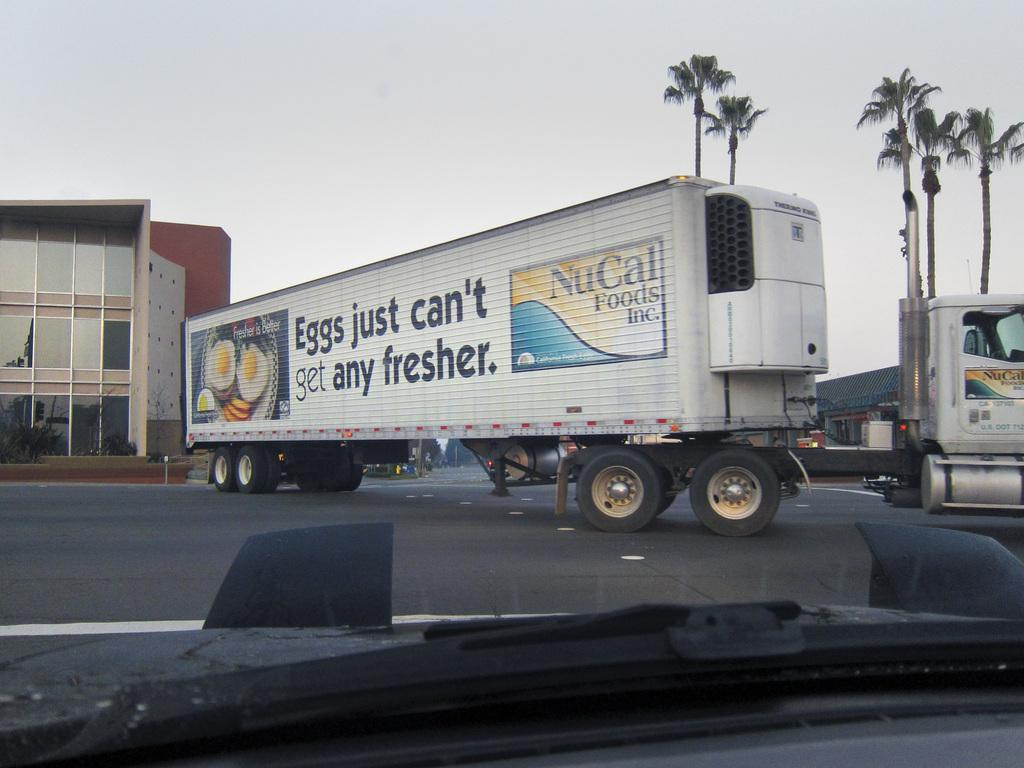What is happening on the road in the image? There are vehicles on the road in the image. What can be seen in the distance behind the vehicles? There are buildings and trees in the background of the image. What part of the natural environment is visible in the image? The sky is visible in the background of the image. How many snails can be seen crawling on the vehicles in the image? There are no snails present in the image; it features vehicles on a road with buildings, trees, and the sky in the background. 